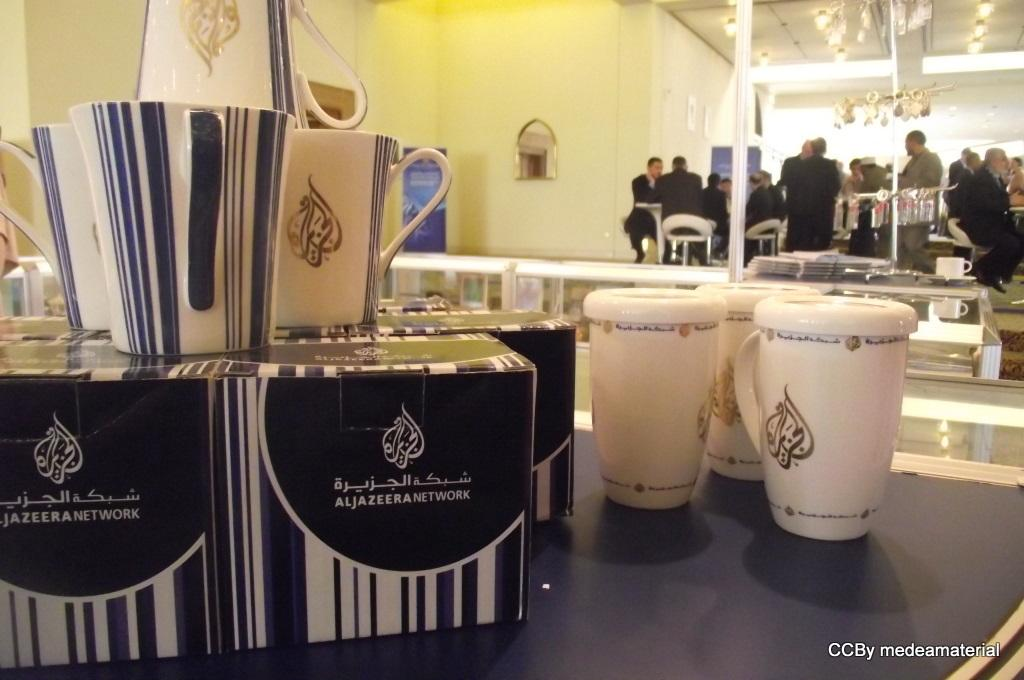<image>
Provide a brief description of the given image. Several items including some boxes with foreign writing on them and some porcelain cups with the writing sit on top of a counter in a store. 